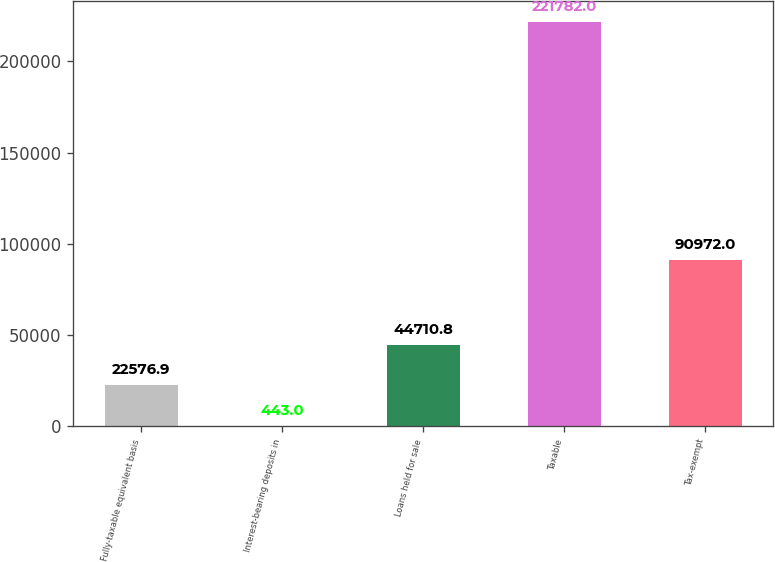<chart> <loc_0><loc_0><loc_500><loc_500><bar_chart><fcel>Fully-taxable equivalent basis<fcel>Interest-bearing deposits in<fcel>Loans held for sale<fcel>Taxable<fcel>Tax-exempt<nl><fcel>22576.9<fcel>443<fcel>44710.8<fcel>221782<fcel>90972<nl></chart> 